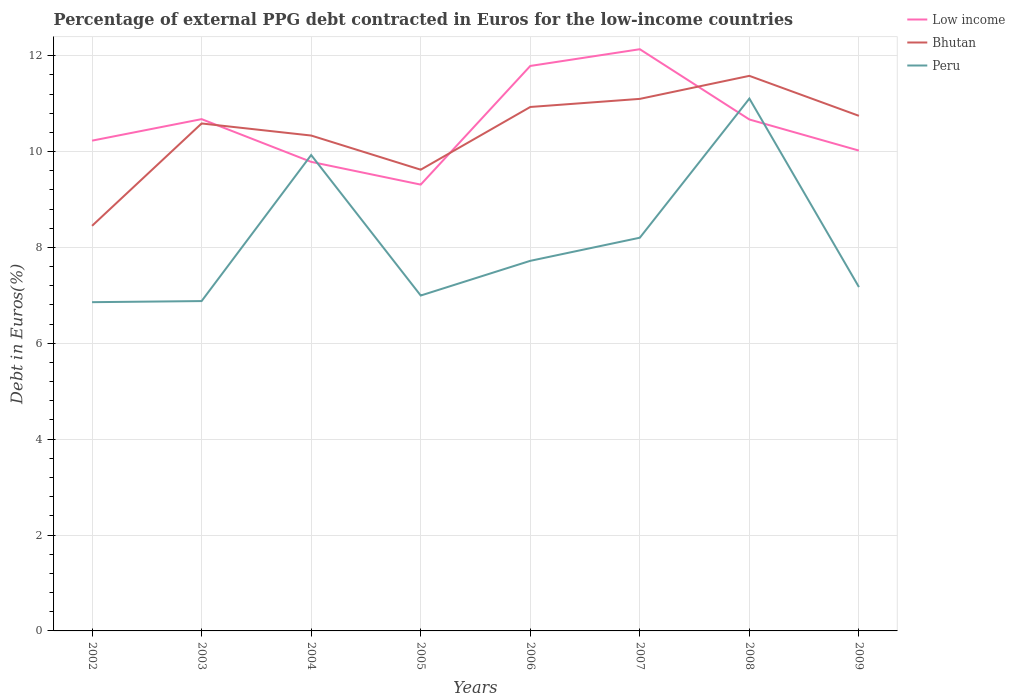Is the number of lines equal to the number of legend labels?
Your response must be concise. Yes. Across all years, what is the maximum percentage of external PPG debt contracted in Euros in Low income?
Your answer should be very brief. 9.31. What is the total percentage of external PPG debt contracted in Euros in Peru in the graph?
Provide a succinct answer. -0.18. What is the difference between the highest and the second highest percentage of external PPG debt contracted in Euros in Bhutan?
Provide a short and direct response. 3.13. Is the percentage of external PPG debt contracted in Euros in Low income strictly greater than the percentage of external PPG debt contracted in Euros in Peru over the years?
Your answer should be very brief. No. How many years are there in the graph?
Keep it short and to the point. 8. Does the graph contain any zero values?
Ensure brevity in your answer.  No. Does the graph contain grids?
Offer a very short reply. Yes. How are the legend labels stacked?
Provide a short and direct response. Vertical. What is the title of the graph?
Your response must be concise. Percentage of external PPG debt contracted in Euros for the low-income countries. Does "Mexico" appear as one of the legend labels in the graph?
Your answer should be very brief. No. What is the label or title of the X-axis?
Provide a succinct answer. Years. What is the label or title of the Y-axis?
Provide a succinct answer. Debt in Euros(%). What is the Debt in Euros(%) in Low income in 2002?
Provide a short and direct response. 10.23. What is the Debt in Euros(%) in Bhutan in 2002?
Your response must be concise. 8.45. What is the Debt in Euros(%) in Peru in 2002?
Provide a succinct answer. 6.86. What is the Debt in Euros(%) in Low income in 2003?
Your response must be concise. 10.68. What is the Debt in Euros(%) in Bhutan in 2003?
Give a very brief answer. 10.59. What is the Debt in Euros(%) in Peru in 2003?
Provide a succinct answer. 6.88. What is the Debt in Euros(%) of Low income in 2004?
Your answer should be very brief. 9.78. What is the Debt in Euros(%) in Bhutan in 2004?
Ensure brevity in your answer.  10.33. What is the Debt in Euros(%) in Peru in 2004?
Give a very brief answer. 9.93. What is the Debt in Euros(%) in Low income in 2005?
Your answer should be very brief. 9.31. What is the Debt in Euros(%) in Bhutan in 2005?
Give a very brief answer. 9.62. What is the Debt in Euros(%) in Peru in 2005?
Give a very brief answer. 7. What is the Debt in Euros(%) in Low income in 2006?
Offer a terse response. 11.79. What is the Debt in Euros(%) in Bhutan in 2006?
Your response must be concise. 10.93. What is the Debt in Euros(%) of Peru in 2006?
Make the answer very short. 7.72. What is the Debt in Euros(%) of Low income in 2007?
Make the answer very short. 12.13. What is the Debt in Euros(%) of Bhutan in 2007?
Your answer should be very brief. 11.1. What is the Debt in Euros(%) of Peru in 2007?
Provide a succinct answer. 8.2. What is the Debt in Euros(%) of Low income in 2008?
Your answer should be compact. 10.67. What is the Debt in Euros(%) in Bhutan in 2008?
Give a very brief answer. 11.58. What is the Debt in Euros(%) in Peru in 2008?
Your answer should be very brief. 11.11. What is the Debt in Euros(%) in Low income in 2009?
Ensure brevity in your answer.  10.02. What is the Debt in Euros(%) in Bhutan in 2009?
Offer a very short reply. 10.75. What is the Debt in Euros(%) of Peru in 2009?
Your response must be concise. 7.17. Across all years, what is the maximum Debt in Euros(%) in Low income?
Make the answer very short. 12.13. Across all years, what is the maximum Debt in Euros(%) in Bhutan?
Provide a short and direct response. 11.58. Across all years, what is the maximum Debt in Euros(%) in Peru?
Keep it short and to the point. 11.11. Across all years, what is the minimum Debt in Euros(%) in Low income?
Your response must be concise. 9.31. Across all years, what is the minimum Debt in Euros(%) of Bhutan?
Offer a very short reply. 8.45. Across all years, what is the minimum Debt in Euros(%) in Peru?
Provide a short and direct response. 6.86. What is the total Debt in Euros(%) of Low income in the graph?
Give a very brief answer. 84.61. What is the total Debt in Euros(%) of Bhutan in the graph?
Offer a very short reply. 83.34. What is the total Debt in Euros(%) of Peru in the graph?
Give a very brief answer. 64.86. What is the difference between the Debt in Euros(%) in Low income in 2002 and that in 2003?
Provide a succinct answer. -0.45. What is the difference between the Debt in Euros(%) of Bhutan in 2002 and that in 2003?
Offer a terse response. -2.14. What is the difference between the Debt in Euros(%) of Peru in 2002 and that in 2003?
Make the answer very short. -0.02. What is the difference between the Debt in Euros(%) of Low income in 2002 and that in 2004?
Your response must be concise. 0.44. What is the difference between the Debt in Euros(%) in Bhutan in 2002 and that in 2004?
Give a very brief answer. -1.88. What is the difference between the Debt in Euros(%) of Peru in 2002 and that in 2004?
Ensure brevity in your answer.  -3.07. What is the difference between the Debt in Euros(%) of Low income in 2002 and that in 2005?
Give a very brief answer. 0.92. What is the difference between the Debt in Euros(%) of Bhutan in 2002 and that in 2005?
Your response must be concise. -1.17. What is the difference between the Debt in Euros(%) in Peru in 2002 and that in 2005?
Offer a terse response. -0.14. What is the difference between the Debt in Euros(%) in Low income in 2002 and that in 2006?
Offer a terse response. -1.56. What is the difference between the Debt in Euros(%) in Bhutan in 2002 and that in 2006?
Keep it short and to the point. -2.48. What is the difference between the Debt in Euros(%) in Peru in 2002 and that in 2006?
Provide a succinct answer. -0.86. What is the difference between the Debt in Euros(%) of Low income in 2002 and that in 2007?
Ensure brevity in your answer.  -1.91. What is the difference between the Debt in Euros(%) of Bhutan in 2002 and that in 2007?
Offer a very short reply. -2.65. What is the difference between the Debt in Euros(%) in Peru in 2002 and that in 2007?
Give a very brief answer. -1.34. What is the difference between the Debt in Euros(%) of Low income in 2002 and that in 2008?
Provide a short and direct response. -0.44. What is the difference between the Debt in Euros(%) of Bhutan in 2002 and that in 2008?
Your answer should be compact. -3.13. What is the difference between the Debt in Euros(%) in Peru in 2002 and that in 2008?
Offer a very short reply. -4.25. What is the difference between the Debt in Euros(%) in Low income in 2002 and that in 2009?
Ensure brevity in your answer.  0.21. What is the difference between the Debt in Euros(%) of Bhutan in 2002 and that in 2009?
Keep it short and to the point. -2.29. What is the difference between the Debt in Euros(%) of Peru in 2002 and that in 2009?
Offer a terse response. -0.31. What is the difference between the Debt in Euros(%) in Low income in 2003 and that in 2004?
Give a very brief answer. 0.89. What is the difference between the Debt in Euros(%) of Bhutan in 2003 and that in 2004?
Provide a succinct answer. 0.25. What is the difference between the Debt in Euros(%) in Peru in 2003 and that in 2004?
Offer a very short reply. -3.05. What is the difference between the Debt in Euros(%) in Low income in 2003 and that in 2005?
Offer a terse response. 1.37. What is the difference between the Debt in Euros(%) of Bhutan in 2003 and that in 2005?
Make the answer very short. 0.96. What is the difference between the Debt in Euros(%) in Peru in 2003 and that in 2005?
Your response must be concise. -0.12. What is the difference between the Debt in Euros(%) of Low income in 2003 and that in 2006?
Your response must be concise. -1.11. What is the difference between the Debt in Euros(%) in Bhutan in 2003 and that in 2006?
Keep it short and to the point. -0.34. What is the difference between the Debt in Euros(%) in Peru in 2003 and that in 2006?
Your answer should be very brief. -0.84. What is the difference between the Debt in Euros(%) of Low income in 2003 and that in 2007?
Provide a short and direct response. -1.46. What is the difference between the Debt in Euros(%) of Bhutan in 2003 and that in 2007?
Your response must be concise. -0.51. What is the difference between the Debt in Euros(%) of Peru in 2003 and that in 2007?
Your answer should be very brief. -1.32. What is the difference between the Debt in Euros(%) of Low income in 2003 and that in 2008?
Offer a terse response. 0.01. What is the difference between the Debt in Euros(%) in Bhutan in 2003 and that in 2008?
Provide a succinct answer. -0.99. What is the difference between the Debt in Euros(%) in Peru in 2003 and that in 2008?
Your answer should be compact. -4.22. What is the difference between the Debt in Euros(%) in Low income in 2003 and that in 2009?
Provide a succinct answer. 0.66. What is the difference between the Debt in Euros(%) of Bhutan in 2003 and that in 2009?
Offer a terse response. -0.16. What is the difference between the Debt in Euros(%) in Peru in 2003 and that in 2009?
Provide a succinct answer. -0.29. What is the difference between the Debt in Euros(%) of Low income in 2004 and that in 2005?
Your answer should be compact. 0.47. What is the difference between the Debt in Euros(%) in Bhutan in 2004 and that in 2005?
Offer a very short reply. 0.71. What is the difference between the Debt in Euros(%) of Peru in 2004 and that in 2005?
Offer a very short reply. 2.93. What is the difference between the Debt in Euros(%) of Low income in 2004 and that in 2006?
Provide a succinct answer. -2. What is the difference between the Debt in Euros(%) of Bhutan in 2004 and that in 2006?
Offer a very short reply. -0.6. What is the difference between the Debt in Euros(%) of Peru in 2004 and that in 2006?
Your answer should be very brief. 2.21. What is the difference between the Debt in Euros(%) of Low income in 2004 and that in 2007?
Your answer should be very brief. -2.35. What is the difference between the Debt in Euros(%) in Bhutan in 2004 and that in 2007?
Make the answer very short. -0.76. What is the difference between the Debt in Euros(%) of Peru in 2004 and that in 2007?
Make the answer very short. 1.72. What is the difference between the Debt in Euros(%) in Low income in 2004 and that in 2008?
Your answer should be very brief. -0.88. What is the difference between the Debt in Euros(%) of Bhutan in 2004 and that in 2008?
Offer a very short reply. -1.25. What is the difference between the Debt in Euros(%) of Peru in 2004 and that in 2008?
Your answer should be compact. -1.18. What is the difference between the Debt in Euros(%) of Low income in 2004 and that in 2009?
Offer a terse response. -0.24. What is the difference between the Debt in Euros(%) of Bhutan in 2004 and that in 2009?
Your answer should be very brief. -0.41. What is the difference between the Debt in Euros(%) of Peru in 2004 and that in 2009?
Provide a short and direct response. 2.75. What is the difference between the Debt in Euros(%) in Low income in 2005 and that in 2006?
Offer a very short reply. -2.48. What is the difference between the Debt in Euros(%) of Bhutan in 2005 and that in 2006?
Ensure brevity in your answer.  -1.31. What is the difference between the Debt in Euros(%) of Peru in 2005 and that in 2006?
Your answer should be compact. -0.72. What is the difference between the Debt in Euros(%) in Low income in 2005 and that in 2007?
Offer a very short reply. -2.82. What is the difference between the Debt in Euros(%) in Bhutan in 2005 and that in 2007?
Give a very brief answer. -1.48. What is the difference between the Debt in Euros(%) of Peru in 2005 and that in 2007?
Provide a succinct answer. -1.21. What is the difference between the Debt in Euros(%) of Low income in 2005 and that in 2008?
Your answer should be very brief. -1.36. What is the difference between the Debt in Euros(%) in Bhutan in 2005 and that in 2008?
Your answer should be very brief. -1.96. What is the difference between the Debt in Euros(%) of Peru in 2005 and that in 2008?
Offer a terse response. -4.11. What is the difference between the Debt in Euros(%) of Low income in 2005 and that in 2009?
Your response must be concise. -0.71. What is the difference between the Debt in Euros(%) of Bhutan in 2005 and that in 2009?
Your answer should be compact. -1.12. What is the difference between the Debt in Euros(%) in Peru in 2005 and that in 2009?
Offer a terse response. -0.18. What is the difference between the Debt in Euros(%) in Low income in 2006 and that in 2007?
Your answer should be compact. -0.35. What is the difference between the Debt in Euros(%) in Bhutan in 2006 and that in 2007?
Provide a succinct answer. -0.17. What is the difference between the Debt in Euros(%) in Peru in 2006 and that in 2007?
Keep it short and to the point. -0.48. What is the difference between the Debt in Euros(%) in Low income in 2006 and that in 2008?
Your response must be concise. 1.12. What is the difference between the Debt in Euros(%) of Bhutan in 2006 and that in 2008?
Keep it short and to the point. -0.65. What is the difference between the Debt in Euros(%) in Peru in 2006 and that in 2008?
Offer a very short reply. -3.38. What is the difference between the Debt in Euros(%) in Low income in 2006 and that in 2009?
Make the answer very short. 1.77. What is the difference between the Debt in Euros(%) in Bhutan in 2006 and that in 2009?
Provide a short and direct response. 0.18. What is the difference between the Debt in Euros(%) of Peru in 2006 and that in 2009?
Make the answer very short. 0.55. What is the difference between the Debt in Euros(%) in Low income in 2007 and that in 2008?
Offer a very short reply. 1.47. What is the difference between the Debt in Euros(%) in Bhutan in 2007 and that in 2008?
Provide a short and direct response. -0.48. What is the difference between the Debt in Euros(%) of Peru in 2007 and that in 2008?
Your answer should be very brief. -2.9. What is the difference between the Debt in Euros(%) of Low income in 2007 and that in 2009?
Give a very brief answer. 2.11. What is the difference between the Debt in Euros(%) of Bhutan in 2007 and that in 2009?
Offer a very short reply. 0.35. What is the difference between the Debt in Euros(%) of Peru in 2007 and that in 2009?
Provide a succinct answer. 1.03. What is the difference between the Debt in Euros(%) of Low income in 2008 and that in 2009?
Your response must be concise. 0.65. What is the difference between the Debt in Euros(%) of Bhutan in 2008 and that in 2009?
Your answer should be very brief. 0.83. What is the difference between the Debt in Euros(%) in Peru in 2008 and that in 2009?
Ensure brevity in your answer.  3.93. What is the difference between the Debt in Euros(%) of Low income in 2002 and the Debt in Euros(%) of Bhutan in 2003?
Your response must be concise. -0.36. What is the difference between the Debt in Euros(%) in Low income in 2002 and the Debt in Euros(%) in Peru in 2003?
Your response must be concise. 3.35. What is the difference between the Debt in Euros(%) in Bhutan in 2002 and the Debt in Euros(%) in Peru in 2003?
Your response must be concise. 1.57. What is the difference between the Debt in Euros(%) in Low income in 2002 and the Debt in Euros(%) in Bhutan in 2004?
Keep it short and to the point. -0.11. What is the difference between the Debt in Euros(%) of Low income in 2002 and the Debt in Euros(%) of Peru in 2004?
Keep it short and to the point. 0.3. What is the difference between the Debt in Euros(%) of Bhutan in 2002 and the Debt in Euros(%) of Peru in 2004?
Your answer should be very brief. -1.48. What is the difference between the Debt in Euros(%) in Low income in 2002 and the Debt in Euros(%) in Bhutan in 2005?
Keep it short and to the point. 0.61. What is the difference between the Debt in Euros(%) of Low income in 2002 and the Debt in Euros(%) of Peru in 2005?
Offer a terse response. 3.23. What is the difference between the Debt in Euros(%) in Bhutan in 2002 and the Debt in Euros(%) in Peru in 2005?
Provide a short and direct response. 1.45. What is the difference between the Debt in Euros(%) in Low income in 2002 and the Debt in Euros(%) in Bhutan in 2006?
Your answer should be compact. -0.7. What is the difference between the Debt in Euros(%) of Low income in 2002 and the Debt in Euros(%) of Peru in 2006?
Your answer should be compact. 2.51. What is the difference between the Debt in Euros(%) in Bhutan in 2002 and the Debt in Euros(%) in Peru in 2006?
Your answer should be compact. 0.73. What is the difference between the Debt in Euros(%) in Low income in 2002 and the Debt in Euros(%) in Bhutan in 2007?
Make the answer very short. -0.87. What is the difference between the Debt in Euros(%) of Low income in 2002 and the Debt in Euros(%) of Peru in 2007?
Offer a very short reply. 2.02. What is the difference between the Debt in Euros(%) in Bhutan in 2002 and the Debt in Euros(%) in Peru in 2007?
Offer a terse response. 0.25. What is the difference between the Debt in Euros(%) of Low income in 2002 and the Debt in Euros(%) of Bhutan in 2008?
Give a very brief answer. -1.35. What is the difference between the Debt in Euros(%) of Low income in 2002 and the Debt in Euros(%) of Peru in 2008?
Your answer should be compact. -0.88. What is the difference between the Debt in Euros(%) of Bhutan in 2002 and the Debt in Euros(%) of Peru in 2008?
Offer a very short reply. -2.65. What is the difference between the Debt in Euros(%) of Low income in 2002 and the Debt in Euros(%) of Bhutan in 2009?
Ensure brevity in your answer.  -0.52. What is the difference between the Debt in Euros(%) in Low income in 2002 and the Debt in Euros(%) in Peru in 2009?
Offer a terse response. 3.05. What is the difference between the Debt in Euros(%) of Bhutan in 2002 and the Debt in Euros(%) of Peru in 2009?
Give a very brief answer. 1.28. What is the difference between the Debt in Euros(%) in Low income in 2003 and the Debt in Euros(%) in Bhutan in 2004?
Keep it short and to the point. 0.34. What is the difference between the Debt in Euros(%) of Low income in 2003 and the Debt in Euros(%) of Peru in 2004?
Keep it short and to the point. 0.75. What is the difference between the Debt in Euros(%) in Bhutan in 2003 and the Debt in Euros(%) in Peru in 2004?
Provide a succinct answer. 0.66. What is the difference between the Debt in Euros(%) in Low income in 2003 and the Debt in Euros(%) in Bhutan in 2005?
Provide a short and direct response. 1.05. What is the difference between the Debt in Euros(%) of Low income in 2003 and the Debt in Euros(%) of Peru in 2005?
Make the answer very short. 3.68. What is the difference between the Debt in Euros(%) in Bhutan in 2003 and the Debt in Euros(%) in Peru in 2005?
Offer a very short reply. 3.59. What is the difference between the Debt in Euros(%) of Low income in 2003 and the Debt in Euros(%) of Bhutan in 2006?
Offer a terse response. -0.25. What is the difference between the Debt in Euros(%) in Low income in 2003 and the Debt in Euros(%) in Peru in 2006?
Make the answer very short. 2.96. What is the difference between the Debt in Euros(%) in Bhutan in 2003 and the Debt in Euros(%) in Peru in 2006?
Your answer should be very brief. 2.87. What is the difference between the Debt in Euros(%) of Low income in 2003 and the Debt in Euros(%) of Bhutan in 2007?
Your answer should be very brief. -0.42. What is the difference between the Debt in Euros(%) of Low income in 2003 and the Debt in Euros(%) of Peru in 2007?
Your answer should be very brief. 2.47. What is the difference between the Debt in Euros(%) in Bhutan in 2003 and the Debt in Euros(%) in Peru in 2007?
Give a very brief answer. 2.38. What is the difference between the Debt in Euros(%) of Low income in 2003 and the Debt in Euros(%) of Bhutan in 2008?
Keep it short and to the point. -0.9. What is the difference between the Debt in Euros(%) of Low income in 2003 and the Debt in Euros(%) of Peru in 2008?
Your answer should be very brief. -0.43. What is the difference between the Debt in Euros(%) in Bhutan in 2003 and the Debt in Euros(%) in Peru in 2008?
Offer a terse response. -0.52. What is the difference between the Debt in Euros(%) in Low income in 2003 and the Debt in Euros(%) in Bhutan in 2009?
Provide a succinct answer. -0.07. What is the difference between the Debt in Euros(%) of Low income in 2003 and the Debt in Euros(%) of Peru in 2009?
Your answer should be very brief. 3.5. What is the difference between the Debt in Euros(%) in Bhutan in 2003 and the Debt in Euros(%) in Peru in 2009?
Offer a terse response. 3.41. What is the difference between the Debt in Euros(%) of Low income in 2004 and the Debt in Euros(%) of Bhutan in 2005?
Your answer should be compact. 0.16. What is the difference between the Debt in Euros(%) of Low income in 2004 and the Debt in Euros(%) of Peru in 2005?
Give a very brief answer. 2.79. What is the difference between the Debt in Euros(%) in Bhutan in 2004 and the Debt in Euros(%) in Peru in 2005?
Keep it short and to the point. 3.34. What is the difference between the Debt in Euros(%) of Low income in 2004 and the Debt in Euros(%) of Bhutan in 2006?
Your answer should be very brief. -1.14. What is the difference between the Debt in Euros(%) in Low income in 2004 and the Debt in Euros(%) in Peru in 2006?
Make the answer very short. 2.06. What is the difference between the Debt in Euros(%) in Bhutan in 2004 and the Debt in Euros(%) in Peru in 2006?
Your response must be concise. 2.61. What is the difference between the Debt in Euros(%) in Low income in 2004 and the Debt in Euros(%) in Bhutan in 2007?
Your answer should be very brief. -1.31. What is the difference between the Debt in Euros(%) of Low income in 2004 and the Debt in Euros(%) of Peru in 2007?
Provide a succinct answer. 1.58. What is the difference between the Debt in Euros(%) in Bhutan in 2004 and the Debt in Euros(%) in Peru in 2007?
Offer a very short reply. 2.13. What is the difference between the Debt in Euros(%) in Low income in 2004 and the Debt in Euros(%) in Bhutan in 2008?
Make the answer very short. -1.79. What is the difference between the Debt in Euros(%) of Low income in 2004 and the Debt in Euros(%) of Peru in 2008?
Ensure brevity in your answer.  -1.32. What is the difference between the Debt in Euros(%) in Bhutan in 2004 and the Debt in Euros(%) in Peru in 2008?
Make the answer very short. -0.77. What is the difference between the Debt in Euros(%) of Low income in 2004 and the Debt in Euros(%) of Bhutan in 2009?
Your answer should be compact. -0.96. What is the difference between the Debt in Euros(%) of Low income in 2004 and the Debt in Euros(%) of Peru in 2009?
Provide a succinct answer. 2.61. What is the difference between the Debt in Euros(%) of Bhutan in 2004 and the Debt in Euros(%) of Peru in 2009?
Offer a terse response. 3.16. What is the difference between the Debt in Euros(%) in Low income in 2005 and the Debt in Euros(%) in Bhutan in 2006?
Provide a short and direct response. -1.62. What is the difference between the Debt in Euros(%) of Low income in 2005 and the Debt in Euros(%) of Peru in 2006?
Offer a very short reply. 1.59. What is the difference between the Debt in Euros(%) of Bhutan in 2005 and the Debt in Euros(%) of Peru in 2006?
Your answer should be compact. 1.9. What is the difference between the Debt in Euros(%) in Low income in 2005 and the Debt in Euros(%) in Bhutan in 2007?
Provide a short and direct response. -1.79. What is the difference between the Debt in Euros(%) in Low income in 2005 and the Debt in Euros(%) in Peru in 2007?
Provide a succinct answer. 1.11. What is the difference between the Debt in Euros(%) in Bhutan in 2005 and the Debt in Euros(%) in Peru in 2007?
Make the answer very short. 1.42. What is the difference between the Debt in Euros(%) in Low income in 2005 and the Debt in Euros(%) in Bhutan in 2008?
Your answer should be compact. -2.27. What is the difference between the Debt in Euros(%) in Low income in 2005 and the Debt in Euros(%) in Peru in 2008?
Give a very brief answer. -1.79. What is the difference between the Debt in Euros(%) of Bhutan in 2005 and the Debt in Euros(%) of Peru in 2008?
Provide a succinct answer. -1.48. What is the difference between the Debt in Euros(%) of Low income in 2005 and the Debt in Euros(%) of Bhutan in 2009?
Ensure brevity in your answer.  -1.43. What is the difference between the Debt in Euros(%) of Low income in 2005 and the Debt in Euros(%) of Peru in 2009?
Your answer should be very brief. 2.14. What is the difference between the Debt in Euros(%) of Bhutan in 2005 and the Debt in Euros(%) of Peru in 2009?
Your answer should be very brief. 2.45. What is the difference between the Debt in Euros(%) of Low income in 2006 and the Debt in Euros(%) of Bhutan in 2007?
Your answer should be compact. 0.69. What is the difference between the Debt in Euros(%) in Low income in 2006 and the Debt in Euros(%) in Peru in 2007?
Ensure brevity in your answer.  3.58. What is the difference between the Debt in Euros(%) of Bhutan in 2006 and the Debt in Euros(%) of Peru in 2007?
Ensure brevity in your answer.  2.73. What is the difference between the Debt in Euros(%) in Low income in 2006 and the Debt in Euros(%) in Bhutan in 2008?
Give a very brief answer. 0.21. What is the difference between the Debt in Euros(%) of Low income in 2006 and the Debt in Euros(%) of Peru in 2008?
Give a very brief answer. 0.68. What is the difference between the Debt in Euros(%) in Bhutan in 2006 and the Debt in Euros(%) in Peru in 2008?
Ensure brevity in your answer.  -0.18. What is the difference between the Debt in Euros(%) of Low income in 2006 and the Debt in Euros(%) of Bhutan in 2009?
Provide a succinct answer. 1.04. What is the difference between the Debt in Euros(%) in Low income in 2006 and the Debt in Euros(%) in Peru in 2009?
Offer a terse response. 4.61. What is the difference between the Debt in Euros(%) in Bhutan in 2006 and the Debt in Euros(%) in Peru in 2009?
Offer a very short reply. 3.76. What is the difference between the Debt in Euros(%) in Low income in 2007 and the Debt in Euros(%) in Bhutan in 2008?
Provide a succinct answer. 0.56. What is the difference between the Debt in Euros(%) of Low income in 2007 and the Debt in Euros(%) of Peru in 2008?
Make the answer very short. 1.03. What is the difference between the Debt in Euros(%) in Bhutan in 2007 and the Debt in Euros(%) in Peru in 2008?
Provide a succinct answer. -0.01. What is the difference between the Debt in Euros(%) in Low income in 2007 and the Debt in Euros(%) in Bhutan in 2009?
Make the answer very short. 1.39. What is the difference between the Debt in Euros(%) of Low income in 2007 and the Debt in Euros(%) of Peru in 2009?
Make the answer very short. 4.96. What is the difference between the Debt in Euros(%) in Bhutan in 2007 and the Debt in Euros(%) in Peru in 2009?
Your answer should be compact. 3.93. What is the difference between the Debt in Euros(%) of Low income in 2008 and the Debt in Euros(%) of Bhutan in 2009?
Keep it short and to the point. -0.08. What is the difference between the Debt in Euros(%) in Low income in 2008 and the Debt in Euros(%) in Peru in 2009?
Your answer should be compact. 3.5. What is the difference between the Debt in Euros(%) in Bhutan in 2008 and the Debt in Euros(%) in Peru in 2009?
Provide a short and direct response. 4.41. What is the average Debt in Euros(%) in Low income per year?
Offer a terse response. 10.58. What is the average Debt in Euros(%) of Bhutan per year?
Your response must be concise. 10.42. What is the average Debt in Euros(%) of Peru per year?
Offer a very short reply. 8.11. In the year 2002, what is the difference between the Debt in Euros(%) in Low income and Debt in Euros(%) in Bhutan?
Your answer should be compact. 1.78. In the year 2002, what is the difference between the Debt in Euros(%) of Low income and Debt in Euros(%) of Peru?
Provide a short and direct response. 3.37. In the year 2002, what is the difference between the Debt in Euros(%) of Bhutan and Debt in Euros(%) of Peru?
Provide a succinct answer. 1.59. In the year 2003, what is the difference between the Debt in Euros(%) in Low income and Debt in Euros(%) in Bhutan?
Ensure brevity in your answer.  0.09. In the year 2003, what is the difference between the Debt in Euros(%) of Low income and Debt in Euros(%) of Peru?
Your response must be concise. 3.8. In the year 2003, what is the difference between the Debt in Euros(%) in Bhutan and Debt in Euros(%) in Peru?
Your response must be concise. 3.71. In the year 2004, what is the difference between the Debt in Euros(%) of Low income and Debt in Euros(%) of Bhutan?
Ensure brevity in your answer.  -0.55. In the year 2004, what is the difference between the Debt in Euros(%) of Low income and Debt in Euros(%) of Peru?
Provide a short and direct response. -0.14. In the year 2004, what is the difference between the Debt in Euros(%) of Bhutan and Debt in Euros(%) of Peru?
Your answer should be very brief. 0.41. In the year 2005, what is the difference between the Debt in Euros(%) in Low income and Debt in Euros(%) in Bhutan?
Your response must be concise. -0.31. In the year 2005, what is the difference between the Debt in Euros(%) in Low income and Debt in Euros(%) in Peru?
Your response must be concise. 2.31. In the year 2005, what is the difference between the Debt in Euros(%) in Bhutan and Debt in Euros(%) in Peru?
Provide a short and direct response. 2.62. In the year 2006, what is the difference between the Debt in Euros(%) of Low income and Debt in Euros(%) of Bhutan?
Make the answer very short. 0.86. In the year 2006, what is the difference between the Debt in Euros(%) of Low income and Debt in Euros(%) of Peru?
Give a very brief answer. 4.07. In the year 2006, what is the difference between the Debt in Euros(%) of Bhutan and Debt in Euros(%) of Peru?
Keep it short and to the point. 3.21. In the year 2007, what is the difference between the Debt in Euros(%) of Low income and Debt in Euros(%) of Bhutan?
Provide a short and direct response. 1.04. In the year 2007, what is the difference between the Debt in Euros(%) in Low income and Debt in Euros(%) in Peru?
Your answer should be very brief. 3.93. In the year 2007, what is the difference between the Debt in Euros(%) of Bhutan and Debt in Euros(%) of Peru?
Your response must be concise. 2.9. In the year 2008, what is the difference between the Debt in Euros(%) in Low income and Debt in Euros(%) in Bhutan?
Your answer should be compact. -0.91. In the year 2008, what is the difference between the Debt in Euros(%) in Low income and Debt in Euros(%) in Peru?
Make the answer very short. -0.44. In the year 2008, what is the difference between the Debt in Euros(%) in Bhutan and Debt in Euros(%) in Peru?
Offer a terse response. 0.47. In the year 2009, what is the difference between the Debt in Euros(%) of Low income and Debt in Euros(%) of Bhutan?
Offer a terse response. -0.73. In the year 2009, what is the difference between the Debt in Euros(%) of Low income and Debt in Euros(%) of Peru?
Keep it short and to the point. 2.85. In the year 2009, what is the difference between the Debt in Euros(%) of Bhutan and Debt in Euros(%) of Peru?
Offer a terse response. 3.57. What is the ratio of the Debt in Euros(%) of Low income in 2002 to that in 2003?
Offer a terse response. 0.96. What is the ratio of the Debt in Euros(%) of Bhutan in 2002 to that in 2003?
Provide a succinct answer. 0.8. What is the ratio of the Debt in Euros(%) in Low income in 2002 to that in 2004?
Offer a terse response. 1.05. What is the ratio of the Debt in Euros(%) of Bhutan in 2002 to that in 2004?
Keep it short and to the point. 0.82. What is the ratio of the Debt in Euros(%) in Peru in 2002 to that in 2004?
Offer a very short reply. 0.69. What is the ratio of the Debt in Euros(%) in Low income in 2002 to that in 2005?
Ensure brevity in your answer.  1.1. What is the ratio of the Debt in Euros(%) of Bhutan in 2002 to that in 2005?
Your response must be concise. 0.88. What is the ratio of the Debt in Euros(%) of Peru in 2002 to that in 2005?
Keep it short and to the point. 0.98. What is the ratio of the Debt in Euros(%) in Low income in 2002 to that in 2006?
Make the answer very short. 0.87. What is the ratio of the Debt in Euros(%) of Bhutan in 2002 to that in 2006?
Provide a succinct answer. 0.77. What is the ratio of the Debt in Euros(%) in Peru in 2002 to that in 2006?
Make the answer very short. 0.89. What is the ratio of the Debt in Euros(%) of Low income in 2002 to that in 2007?
Provide a short and direct response. 0.84. What is the ratio of the Debt in Euros(%) in Bhutan in 2002 to that in 2007?
Provide a succinct answer. 0.76. What is the ratio of the Debt in Euros(%) of Peru in 2002 to that in 2007?
Make the answer very short. 0.84. What is the ratio of the Debt in Euros(%) of Low income in 2002 to that in 2008?
Your answer should be very brief. 0.96. What is the ratio of the Debt in Euros(%) of Bhutan in 2002 to that in 2008?
Make the answer very short. 0.73. What is the ratio of the Debt in Euros(%) in Peru in 2002 to that in 2008?
Make the answer very short. 0.62. What is the ratio of the Debt in Euros(%) in Low income in 2002 to that in 2009?
Your response must be concise. 1.02. What is the ratio of the Debt in Euros(%) in Bhutan in 2002 to that in 2009?
Your answer should be compact. 0.79. What is the ratio of the Debt in Euros(%) of Peru in 2002 to that in 2009?
Your answer should be compact. 0.96. What is the ratio of the Debt in Euros(%) in Low income in 2003 to that in 2004?
Keep it short and to the point. 1.09. What is the ratio of the Debt in Euros(%) of Bhutan in 2003 to that in 2004?
Your answer should be compact. 1.02. What is the ratio of the Debt in Euros(%) in Peru in 2003 to that in 2004?
Make the answer very short. 0.69. What is the ratio of the Debt in Euros(%) in Low income in 2003 to that in 2005?
Offer a terse response. 1.15. What is the ratio of the Debt in Euros(%) of Bhutan in 2003 to that in 2005?
Offer a very short reply. 1.1. What is the ratio of the Debt in Euros(%) of Peru in 2003 to that in 2005?
Your answer should be very brief. 0.98. What is the ratio of the Debt in Euros(%) in Low income in 2003 to that in 2006?
Make the answer very short. 0.91. What is the ratio of the Debt in Euros(%) in Bhutan in 2003 to that in 2006?
Make the answer very short. 0.97. What is the ratio of the Debt in Euros(%) in Peru in 2003 to that in 2006?
Ensure brevity in your answer.  0.89. What is the ratio of the Debt in Euros(%) in Low income in 2003 to that in 2007?
Give a very brief answer. 0.88. What is the ratio of the Debt in Euros(%) of Bhutan in 2003 to that in 2007?
Offer a very short reply. 0.95. What is the ratio of the Debt in Euros(%) in Peru in 2003 to that in 2007?
Offer a terse response. 0.84. What is the ratio of the Debt in Euros(%) of Low income in 2003 to that in 2008?
Your answer should be very brief. 1. What is the ratio of the Debt in Euros(%) in Bhutan in 2003 to that in 2008?
Provide a succinct answer. 0.91. What is the ratio of the Debt in Euros(%) in Peru in 2003 to that in 2008?
Your answer should be very brief. 0.62. What is the ratio of the Debt in Euros(%) in Low income in 2003 to that in 2009?
Ensure brevity in your answer.  1.07. What is the ratio of the Debt in Euros(%) of Bhutan in 2003 to that in 2009?
Keep it short and to the point. 0.99. What is the ratio of the Debt in Euros(%) of Peru in 2003 to that in 2009?
Your answer should be compact. 0.96. What is the ratio of the Debt in Euros(%) of Low income in 2004 to that in 2005?
Give a very brief answer. 1.05. What is the ratio of the Debt in Euros(%) in Bhutan in 2004 to that in 2005?
Offer a very short reply. 1.07. What is the ratio of the Debt in Euros(%) of Peru in 2004 to that in 2005?
Make the answer very short. 1.42. What is the ratio of the Debt in Euros(%) of Low income in 2004 to that in 2006?
Ensure brevity in your answer.  0.83. What is the ratio of the Debt in Euros(%) of Bhutan in 2004 to that in 2006?
Your answer should be compact. 0.95. What is the ratio of the Debt in Euros(%) of Peru in 2004 to that in 2006?
Keep it short and to the point. 1.29. What is the ratio of the Debt in Euros(%) of Low income in 2004 to that in 2007?
Provide a short and direct response. 0.81. What is the ratio of the Debt in Euros(%) of Bhutan in 2004 to that in 2007?
Provide a succinct answer. 0.93. What is the ratio of the Debt in Euros(%) of Peru in 2004 to that in 2007?
Keep it short and to the point. 1.21. What is the ratio of the Debt in Euros(%) of Low income in 2004 to that in 2008?
Your answer should be very brief. 0.92. What is the ratio of the Debt in Euros(%) in Bhutan in 2004 to that in 2008?
Your answer should be very brief. 0.89. What is the ratio of the Debt in Euros(%) of Peru in 2004 to that in 2008?
Make the answer very short. 0.89. What is the ratio of the Debt in Euros(%) of Low income in 2004 to that in 2009?
Your answer should be very brief. 0.98. What is the ratio of the Debt in Euros(%) in Bhutan in 2004 to that in 2009?
Offer a very short reply. 0.96. What is the ratio of the Debt in Euros(%) of Peru in 2004 to that in 2009?
Make the answer very short. 1.38. What is the ratio of the Debt in Euros(%) of Low income in 2005 to that in 2006?
Make the answer very short. 0.79. What is the ratio of the Debt in Euros(%) of Bhutan in 2005 to that in 2006?
Provide a short and direct response. 0.88. What is the ratio of the Debt in Euros(%) of Peru in 2005 to that in 2006?
Provide a short and direct response. 0.91. What is the ratio of the Debt in Euros(%) in Low income in 2005 to that in 2007?
Make the answer very short. 0.77. What is the ratio of the Debt in Euros(%) of Bhutan in 2005 to that in 2007?
Provide a short and direct response. 0.87. What is the ratio of the Debt in Euros(%) of Peru in 2005 to that in 2007?
Your answer should be very brief. 0.85. What is the ratio of the Debt in Euros(%) in Low income in 2005 to that in 2008?
Keep it short and to the point. 0.87. What is the ratio of the Debt in Euros(%) in Bhutan in 2005 to that in 2008?
Keep it short and to the point. 0.83. What is the ratio of the Debt in Euros(%) in Peru in 2005 to that in 2008?
Provide a short and direct response. 0.63. What is the ratio of the Debt in Euros(%) in Low income in 2005 to that in 2009?
Offer a very short reply. 0.93. What is the ratio of the Debt in Euros(%) of Bhutan in 2005 to that in 2009?
Provide a short and direct response. 0.9. What is the ratio of the Debt in Euros(%) in Peru in 2005 to that in 2009?
Provide a succinct answer. 0.98. What is the ratio of the Debt in Euros(%) in Low income in 2006 to that in 2007?
Offer a terse response. 0.97. What is the ratio of the Debt in Euros(%) in Peru in 2006 to that in 2007?
Offer a very short reply. 0.94. What is the ratio of the Debt in Euros(%) of Low income in 2006 to that in 2008?
Offer a terse response. 1.1. What is the ratio of the Debt in Euros(%) of Bhutan in 2006 to that in 2008?
Ensure brevity in your answer.  0.94. What is the ratio of the Debt in Euros(%) of Peru in 2006 to that in 2008?
Ensure brevity in your answer.  0.7. What is the ratio of the Debt in Euros(%) of Low income in 2006 to that in 2009?
Your answer should be compact. 1.18. What is the ratio of the Debt in Euros(%) in Bhutan in 2006 to that in 2009?
Your answer should be very brief. 1.02. What is the ratio of the Debt in Euros(%) of Peru in 2006 to that in 2009?
Give a very brief answer. 1.08. What is the ratio of the Debt in Euros(%) of Low income in 2007 to that in 2008?
Provide a succinct answer. 1.14. What is the ratio of the Debt in Euros(%) of Bhutan in 2007 to that in 2008?
Make the answer very short. 0.96. What is the ratio of the Debt in Euros(%) of Peru in 2007 to that in 2008?
Keep it short and to the point. 0.74. What is the ratio of the Debt in Euros(%) in Low income in 2007 to that in 2009?
Your answer should be compact. 1.21. What is the ratio of the Debt in Euros(%) in Bhutan in 2007 to that in 2009?
Your response must be concise. 1.03. What is the ratio of the Debt in Euros(%) in Peru in 2007 to that in 2009?
Give a very brief answer. 1.14. What is the ratio of the Debt in Euros(%) in Low income in 2008 to that in 2009?
Provide a succinct answer. 1.06. What is the ratio of the Debt in Euros(%) in Bhutan in 2008 to that in 2009?
Give a very brief answer. 1.08. What is the ratio of the Debt in Euros(%) in Peru in 2008 to that in 2009?
Your answer should be very brief. 1.55. What is the difference between the highest and the second highest Debt in Euros(%) in Low income?
Your response must be concise. 0.35. What is the difference between the highest and the second highest Debt in Euros(%) in Bhutan?
Offer a very short reply. 0.48. What is the difference between the highest and the second highest Debt in Euros(%) in Peru?
Your answer should be compact. 1.18. What is the difference between the highest and the lowest Debt in Euros(%) in Low income?
Your answer should be compact. 2.82. What is the difference between the highest and the lowest Debt in Euros(%) in Bhutan?
Ensure brevity in your answer.  3.13. What is the difference between the highest and the lowest Debt in Euros(%) of Peru?
Your answer should be very brief. 4.25. 